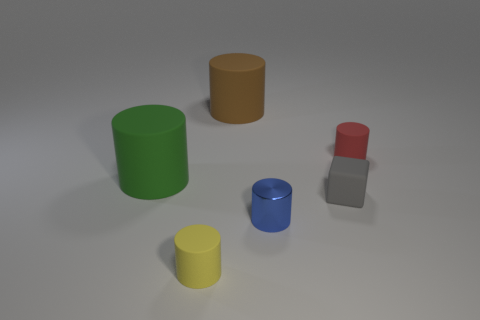Are there any other things that have the same material as the tiny blue cylinder?
Ensure brevity in your answer.  No. The large rubber thing that is in front of the matte thing behind the small matte thing that is right of the block is what shape?
Provide a short and direct response. Cylinder. There is a cylinder that is behind the tiny red rubber cylinder; what is it made of?
Your response must be concise. Rubber. The metallic cylinder that is the same size as the gray object is what color?
Keep it short and to the point. Blue. How many other things are there of the same shape as the gray matte thing?
Provide a short and direct response. 0. Do the green matte object and the brown thing have the same size?
Offer a very short reply. Yes. Is the number of tiny yellow things right of the tiny red matte object greater than the number of tiny things in front of the tiny gray rubber cube?
Ensure brevity in your answer.  No. How many other things are the same size as the blue metallic cylinder?
Offer a very short reply. 3. Is the color of the rubber thing to the left of the small yellow thing the same as the tiny rubber cube?
Make the answer very short. No. Are there more brown cylinders that are to the right of the large brown object than small blue metallic objects?
Offer a terse response. No. 